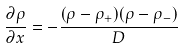Convert formula to latex. <formula><loc_0><loc_0><loc_500><loc_500>\frac { \partial \rho } { \partial x } = - \frac { ( \rho - \rho _ { + } ) ( \rho - \rho _ { - } ) } { D }</formula> 